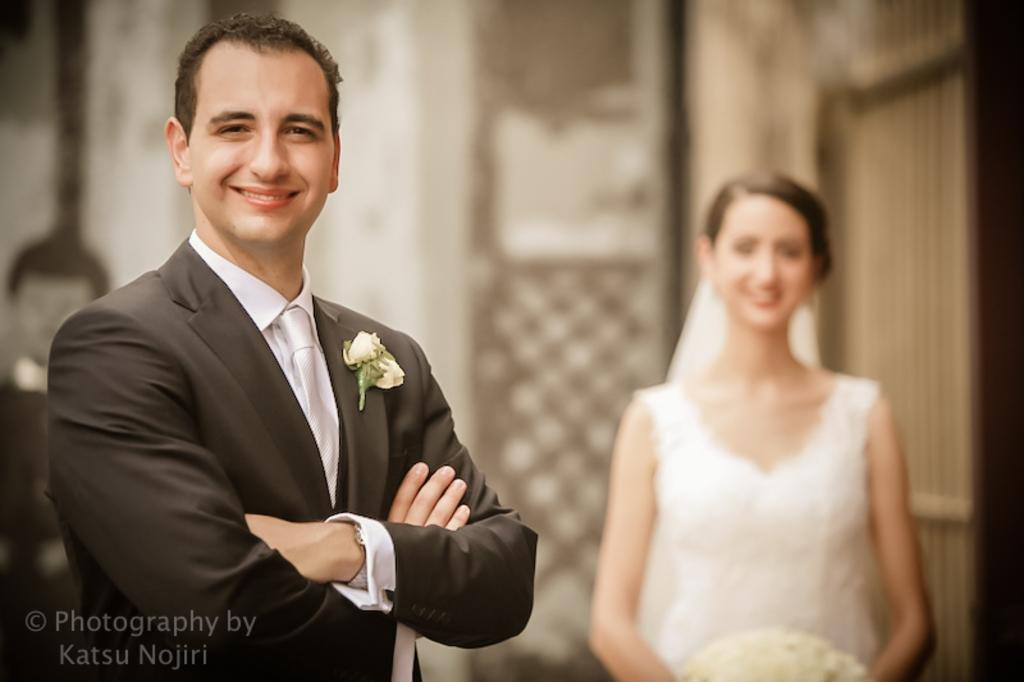How many people are present in the image? There are two people in the image, a man and a woman. What is the woman holding in the image? The woman is holding a bouquet. What can be seen in the background of the image? There is a wall in the background of the image. Where is the throne located in the image? There is no throne present in the image. Are the man and woman in the image sisters? The provided facts do not mention any familial relationship between the man and woman, so we cannot determine if they are sisters. 